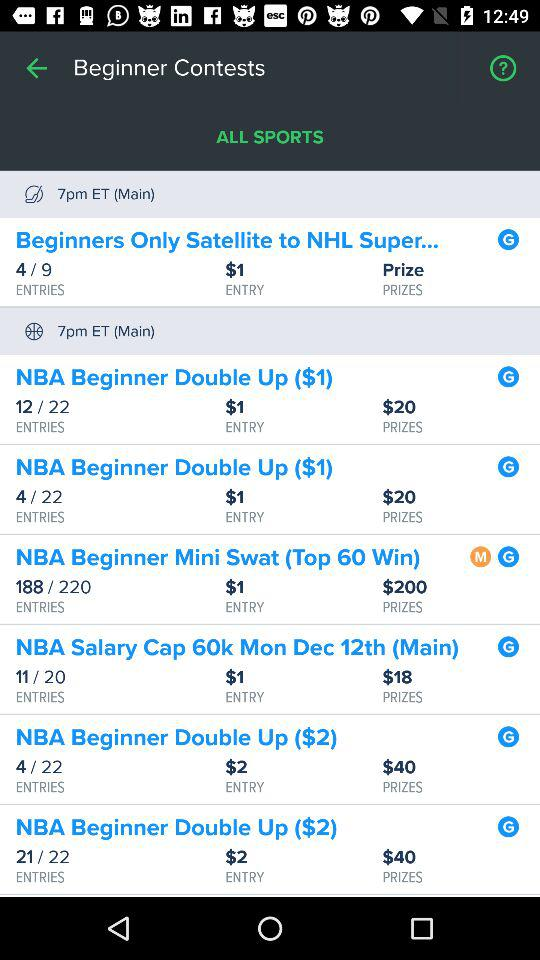How many NBA beginner contests are there with a prize of $2?
Answer the question using a single word or phrase. 2 